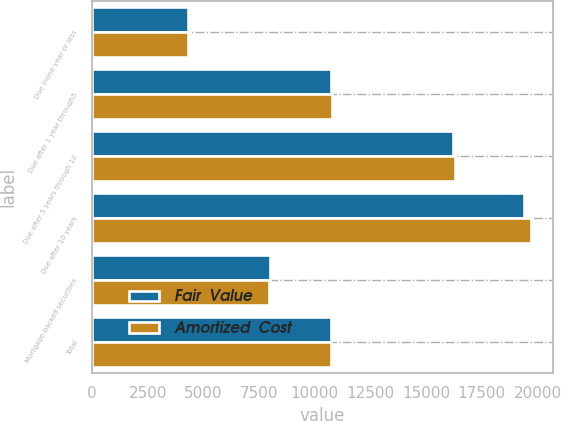Convert chart. <chart><loc_0><loc_0><loc_500><loc_500><stacked_bar_chart><ecel><fcel>Due inone year or less<fcel>Due after 1 year through5<fcel>Due after 5 years through 10<fcel>Due after 10 years<fcel>Mortgage-backed securities<fcel>Total<nl><fcel>Fair  Value<fcel>4296<fcel>10729<fcel>16221<fcel>19373<fcel>7997<fcel>10743<nl><fcel>Amortized  Cost<fcel>4290<fcel>10757<fcel>16281<fcel>19713<fcel>7942<fcel>10743<nl></chart> 